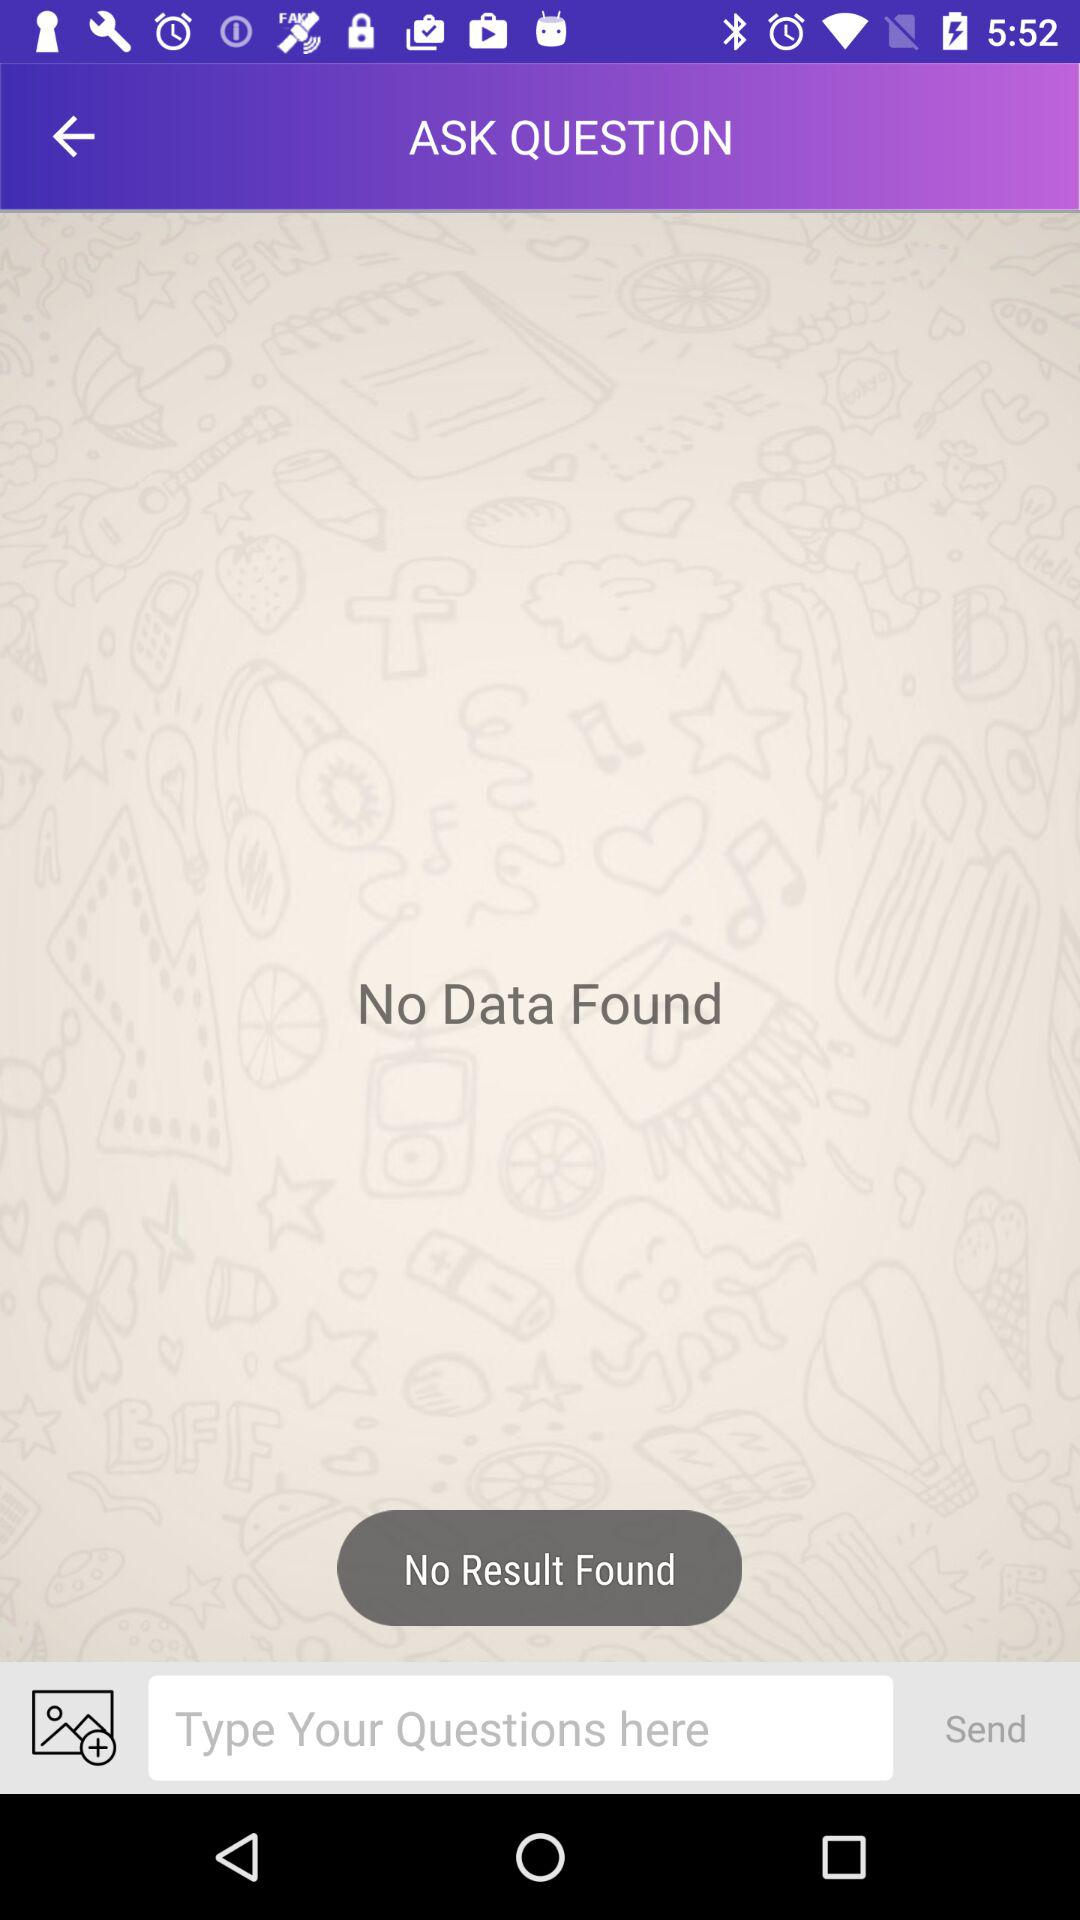Is there any data found? There is no data found. 